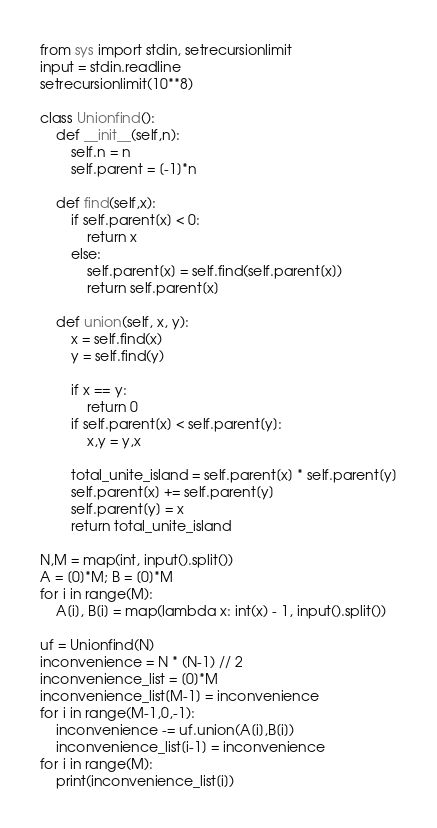Convert code to text. <code><loc_0><loc_0><loc_500><loc_500><_Python_>from sys import stdin, setrecursionlimit
input = stdin.readline
setrecursionlimit(10**8)

class Unionfind():
    def __init__(self,n):
        self.n = n
        self.parent = [-1]*n
    
    def find(self,x):
        if self.parent[x] < 0:
            return x
        else:
            self.parent[x] = self.find(self.parent[x])
            return self.parent[x]
    
    def union(self, x, y):
        x = self.find(x)
        y = self.find(y)
        
        if x == y:
            return 0
        if self.parent[x] < self.parent[y]:
            x,y = y,x
        
        total_unite_island = self.parent[x] * self.parent[y]
        self.parent[x] += self.parent[y]
        self.parent[y] = x
        return total_unite_island

N,M = map(int, input().split())
A = [0]*M; B = [0]*M
for i in range(M):
    A[i], B[i] = map(lambda x: int(x) - 1, input().split())

uf = Unionfind(N)
inconvenience = N * (N-1) // 2
inconvenience_list = [0]*M
inconvenience_list[M-1] = inconvenience
for i in range(M-1,0,-1):
    inconvenience -= uf.union(A[i],B[i])
    inconvenience_list[i-1] = inconvenience
for i in range(M):
    print(inconvenience_list[i])</code> 